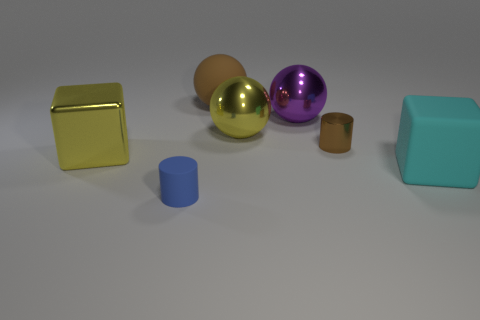Add 1 things. How many objects exist? 8 Subtract all cylinders. How many objects are left? 5 Add 2 tiny cyan shiny blocks. How many tiny cyan shiny blocks exist? 2 Subtract 0 purple cylinders. How many objects are left? 7 Subtract all tiny shiny things. Subtract all large cyan things. How many objects are left? 5 Add 2 large brown matte things. How many large brown matte things are left? 3 